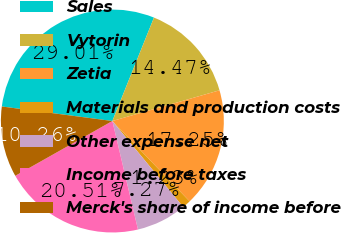Convert chart. <chart><loc_0><loc_0><loc_500><loc_500><pie_chart><fcel>Sales<fcel>Vytorin<fcel>Zetia<fcel>Materials and production costs<fcel>Other expense net<fcel>Income before taxes<fcel>Merck's share of income before<nl><fcel>29.01%<fcel>14.47%<fcel>17.25%<fcel>1.23%<fcel>7.27%<fcel>20.51%<fcel>10.26%<nl></chart> 